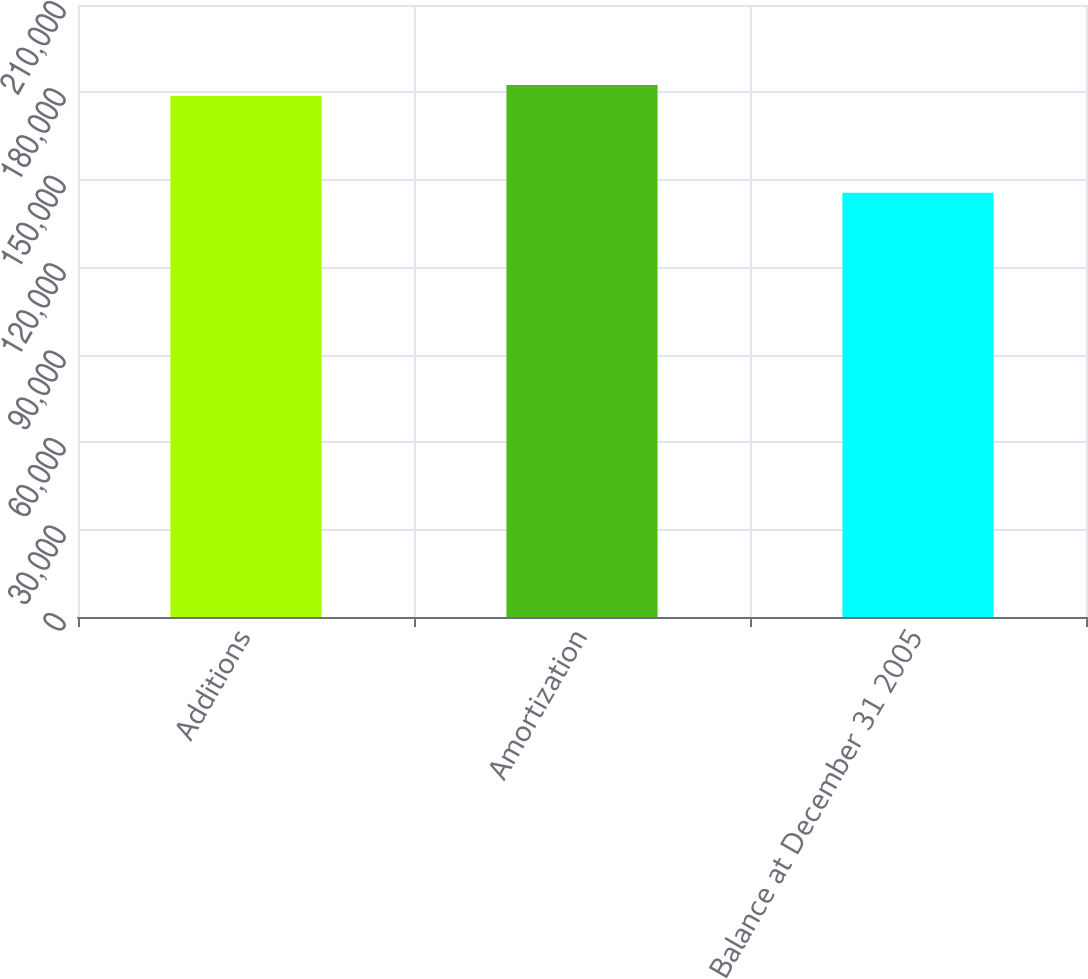Convert chart. <chart><loc_0><loc_0><loc_500><loc_500><bar_chart><fcel>Additions<fcel>Amortization<fcel>Balance at December 31 2005<nl><fcel>178788<fcel>182534<fcel>145612<nl></chart> 